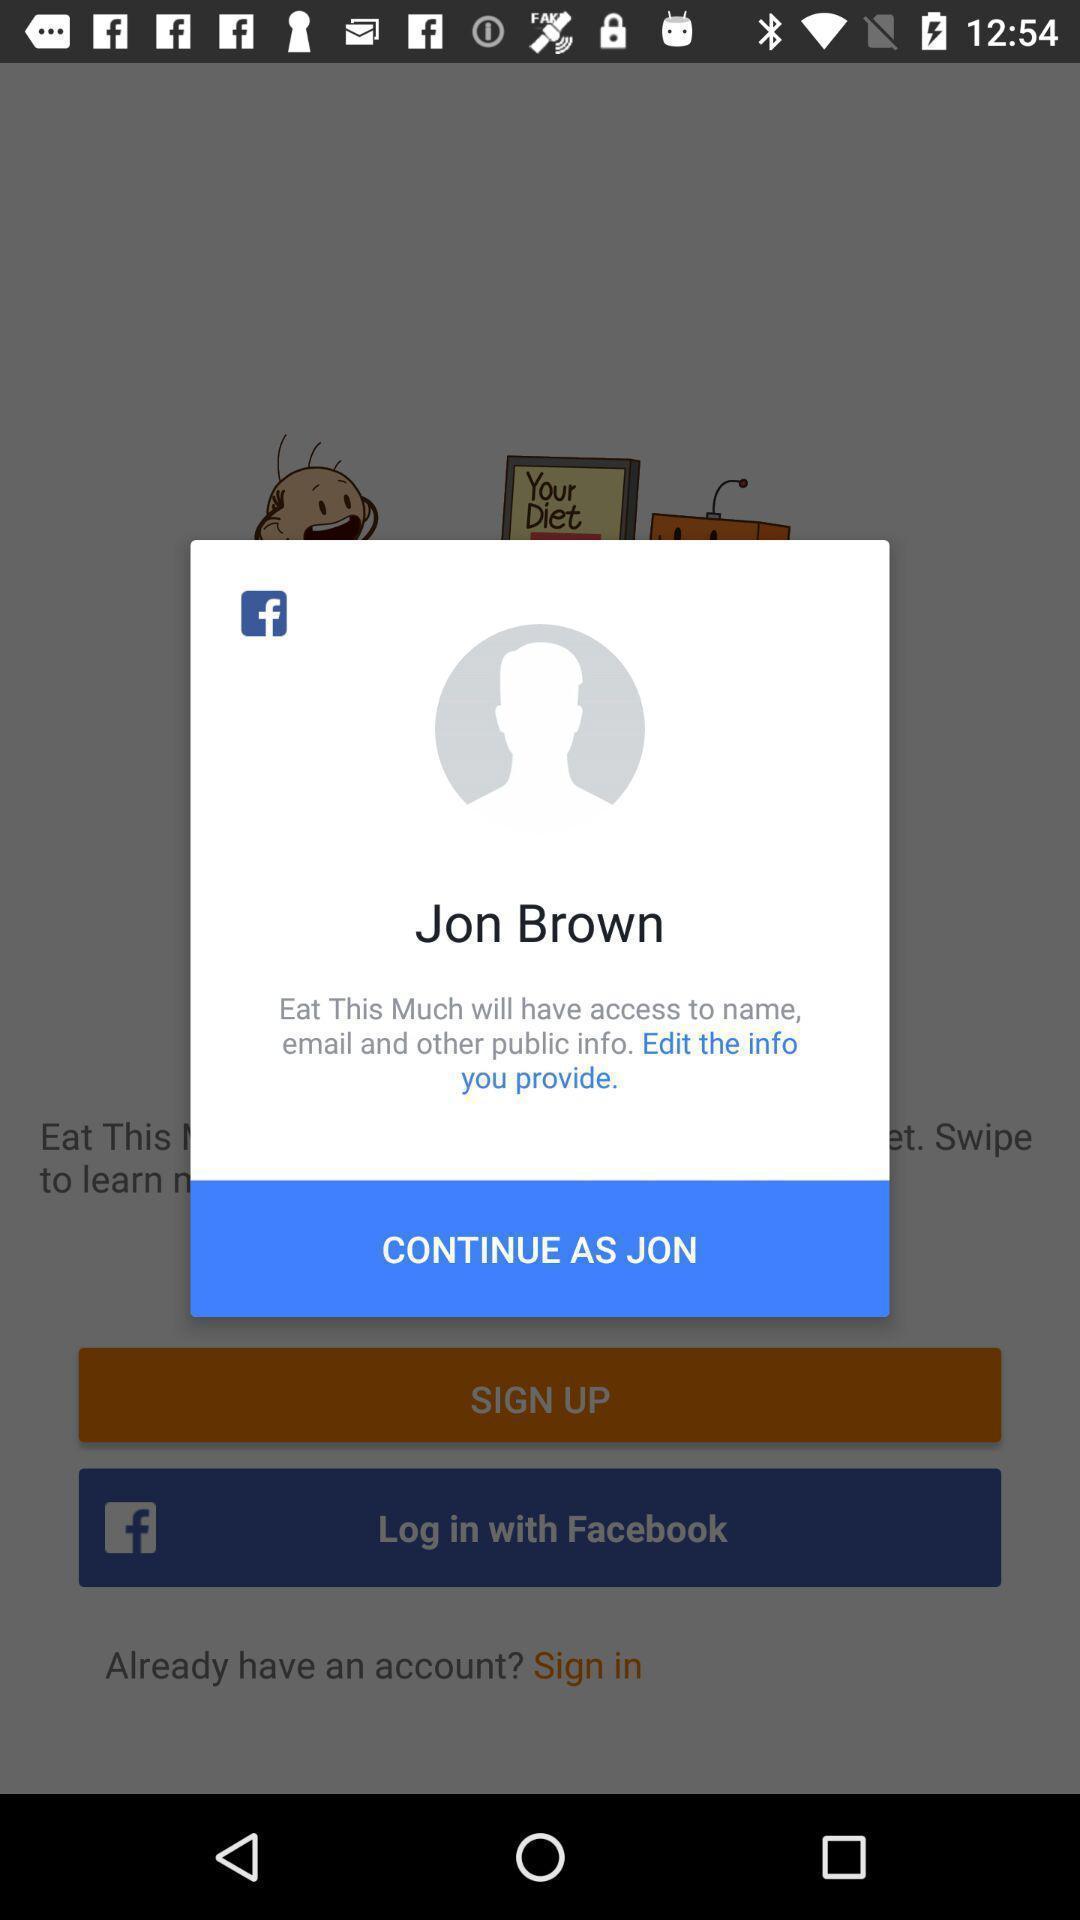Describe this image in words. Pop up screen of profile name. 